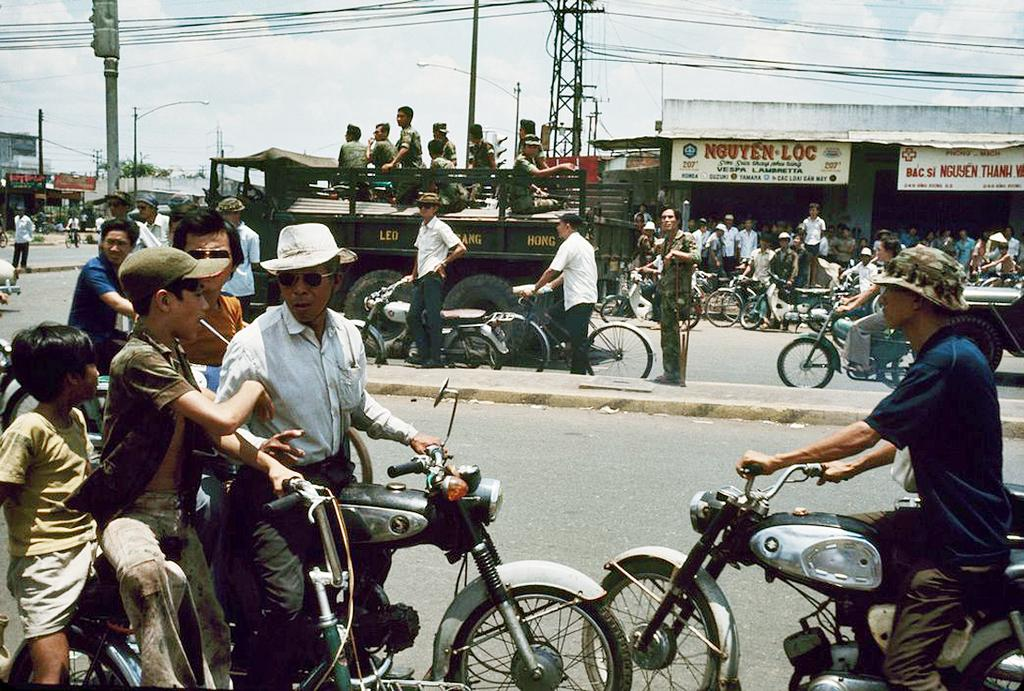What is the main feature of the image? There is a road in the image. What can be seen on the road? There are vehicles on the road, including a motorcycle with people moving on it and a truck carrying men. What else is visible in the image? There are stores visible in the image. What account does the truck driver have with the store owner in the image? There is no mention of an account or any interaction between the truck driver and the store owner in the image. 